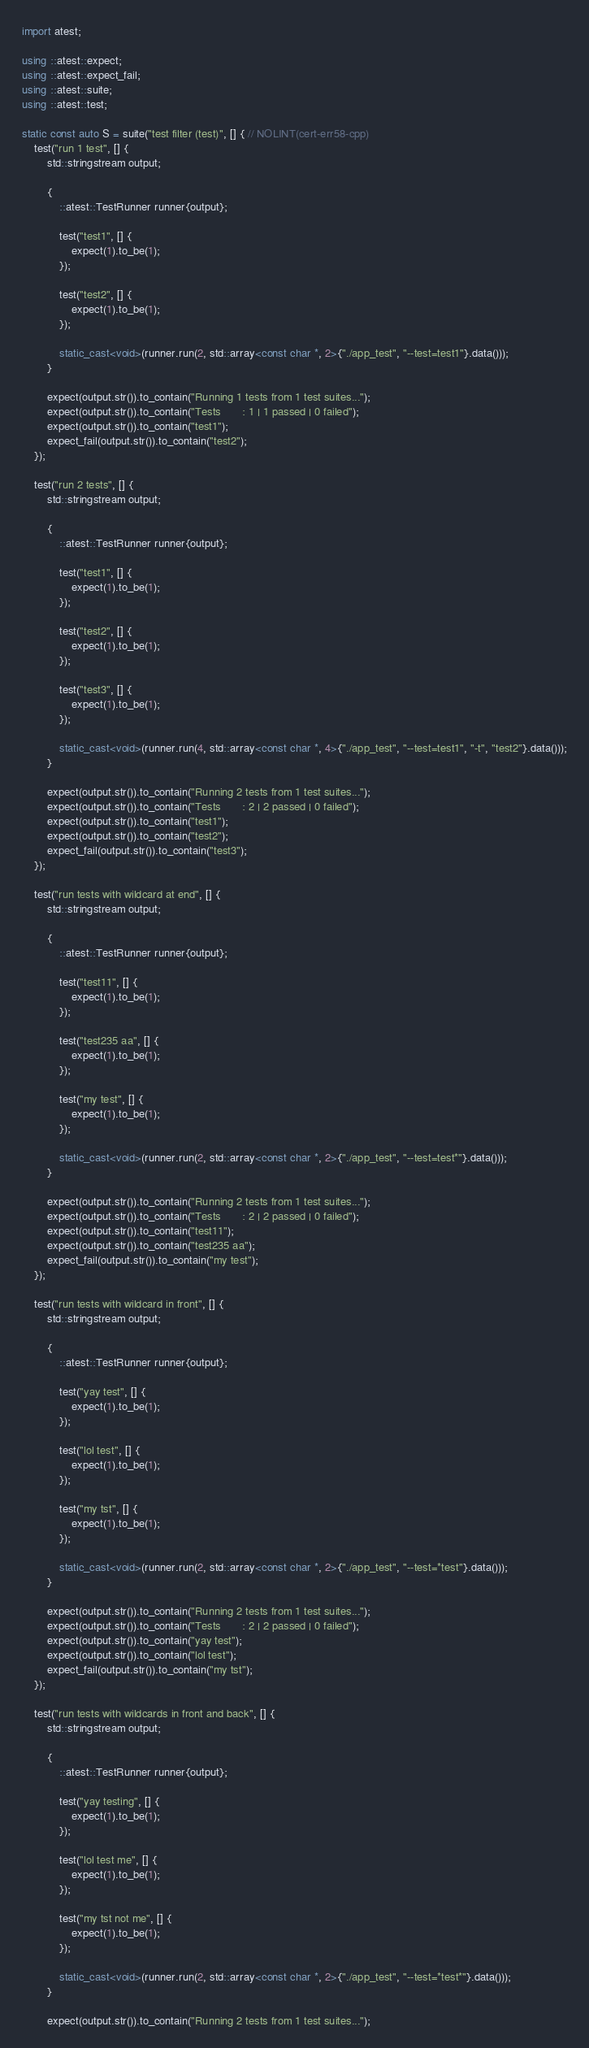Convert code to text. <code><loc_0><loc_0><loc_500><loc_500><_C++_>import atest;

using ::atest::expect;
using ::atest::expect_fail;
using ::atest::suite;
using ::atest::test;

static const auto S = suite("test filter (test)", [] { // NOLINT(cert-err58-cpp)
    test("run 1 test", [] {
        std::stringstream output;

        {
            ::atest::TestRunner runner{output};

            test("test1", [] {
                expect(1).to_be(1);
            });

            test("test2", [] {
                expect(1).to_be(1);
            });

            static_cast<void>(runner.run(2, std::array<const char *, 2>{"./app_test", "--test=test1"}.data()));
        }

        expect(output.str()).to_contain("Running 1 tests from 1 test suites...");
        expect(output.str()).to_contain("Tests       : 1 | 1 passed | 0 failed");
        expect(output.str()).to_contain("test1");
        expect_fail(output.str()).to_contain("test2");
    });

    test("run 2 tests", [] {
        std::stringstream output;

        {
            ::atest::TestRunner runner{output};

            test("test1", [] {
                expect(1).to_be(1);
            });

            test("test2", [] {
                expect(1).to_be(1);
            });

            test("test3", [] {
                expect(1).to_be(1);
            });

            static_cast<void>(runner.run(4, std::array<const char *, 4>{"./app_test", "--test=test1", "-t", "test2"}.data()));
        }

        expect(output.str()).to_contain("Running 2 tests from 1 test suites...");
        expect(output.str()).to_contain("Tests       : 2 | 2 passed | 0 failed");
        expect(output.str()).to_contain("test1");
        expect(output.str()).to_contain("test2");
        expect_fail(output.str()).to_contain("test3");
    });

    test("run tests with wildcard at end", [] {
        std::stringstream output;

        {
            ::atest::TestRunner runner{output};

            test("test11", [] {
                expect(1).to_be(1);
            });

            test("test235 aa", [] {
                expect(1).to_be(1);
            });

            test("my test", [] {
                expect(1).to_be(1);
            });

            static_cast<void>(runner.run(2, std::array<const char *, 2>{"./app_test", "--test=test*"}.data()));
        }

        expect(output.str()).to_contain("Running 2 tests from 1 test suites...");
        expect(output.str()).to_contain("Tests       : 2 | 2 passed | 0 failed");
        expect(output.str()).to_contain("test11");
        expect(output.str()).to_contain("test235 aa");
        expect_fail(output.str()).to_contain("my test");
    });

    test("run tests with wildcard in front", [] {
        std::stringstream output;

        {
            ::atest::TestRunner runner{output};

            test("yay test", [] {
                expect(1).to_be(1);
            });

            test("lol test", [] {
                expect(1).to_be(1);
            });

            test("my tst", [] {
                expect(1).to_be(1);
            });

            static_cast<void>(runner.run(2, std::array<const char *, 2>{"./app_test", "--test=*test"}.data()));
        }

        expect(output.str()).to_contain("Running 2 tests from 1 test suites...");
        expect(output.str()).to_contain("Tests       : 2 | 2 passed | 0 failed");
        expect(output.str()).to_contain("yay test");
        expect(output.str()).to_contain("lol test");
        expect_fail(output.str()).to_contain("my tst");
    });

    test("run tests with wildcards in front and back", [] {
        std::stringstream output;

        {
            ::atest::TestRunner runner{output};

            test("yay testing", [] {
                expect(1).to_be(1);
            });

            test("lol test me", [] {
                expect(1).to_be(1);
            });

            test("my tst not me", [] {
                expect(1).to_be(1);
            });

            static_cast<void>(runner.run(2, std::array<const char *, 2>{"./app_test", "--test=*test*"}.data()));
        }

        expect(output.str()).to_contain("Running 2 tests from 1 test suites...");</code> 